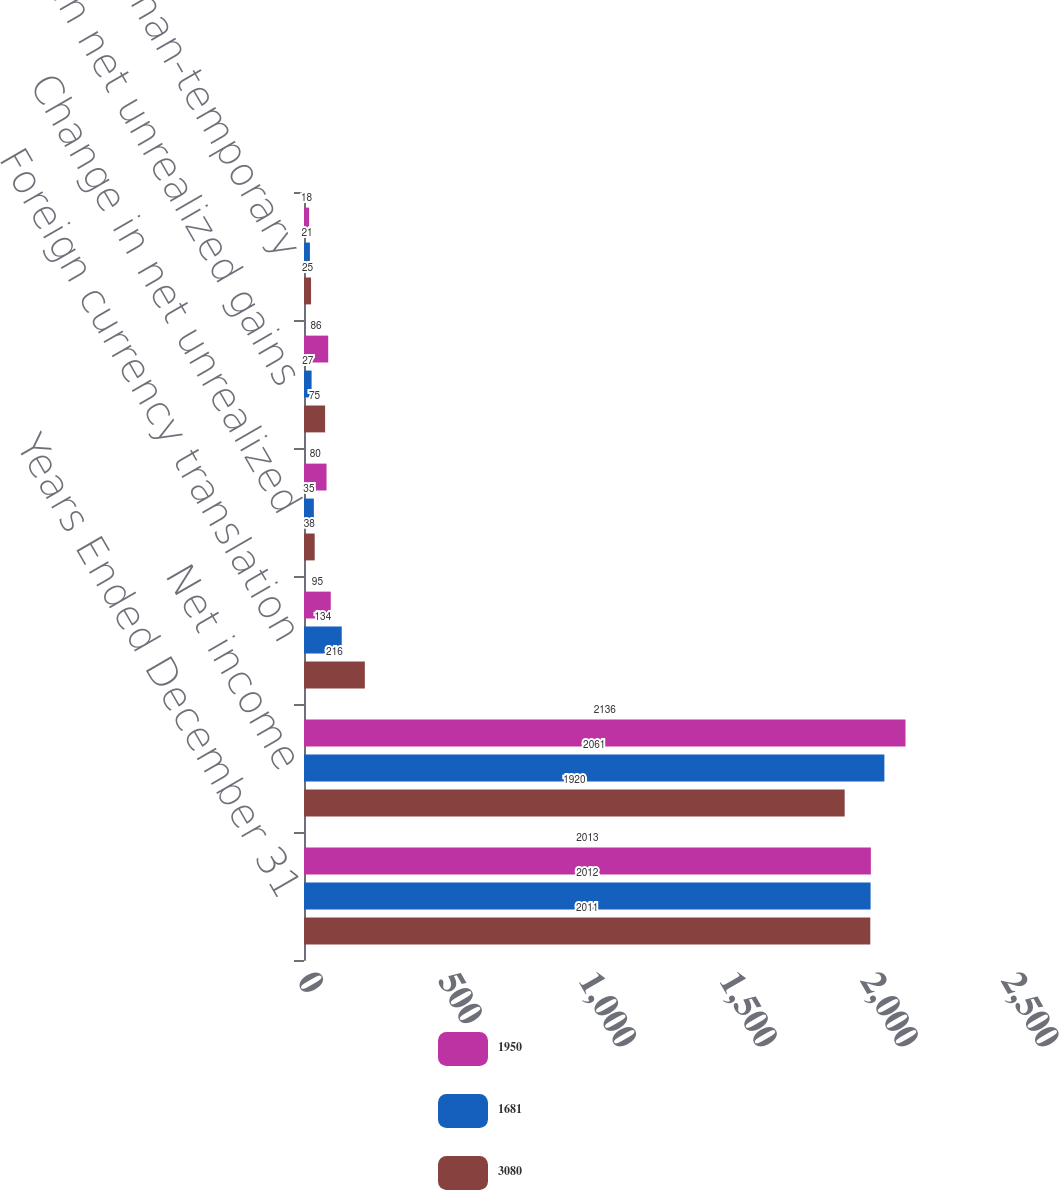Convert chart. <chart><loc_0><loc_0><loc_500><loc_500><stacked_bar_chart><ecel><fcel>Years Ended December 31<fcel>Net income<fcel>Foreign currency translation<fcel>Change in net unrealized<fcel>Change in net unrealized gains<fcel>Other-than-temporary<nl><fcel>1950<fcel>2013<fcel>2136<fcel>95<fcel>80<fcel>86<fcel>18<nl><fcel>1681<fcel>2012<fcel>2061<fcel>134<fcel>35<fcel>27<fcel>21<nl><fcel>3080<fcel>2011<fcel>1920<fcel>216<fcel>38<fcel>75<fcel>25<nl></chart> 